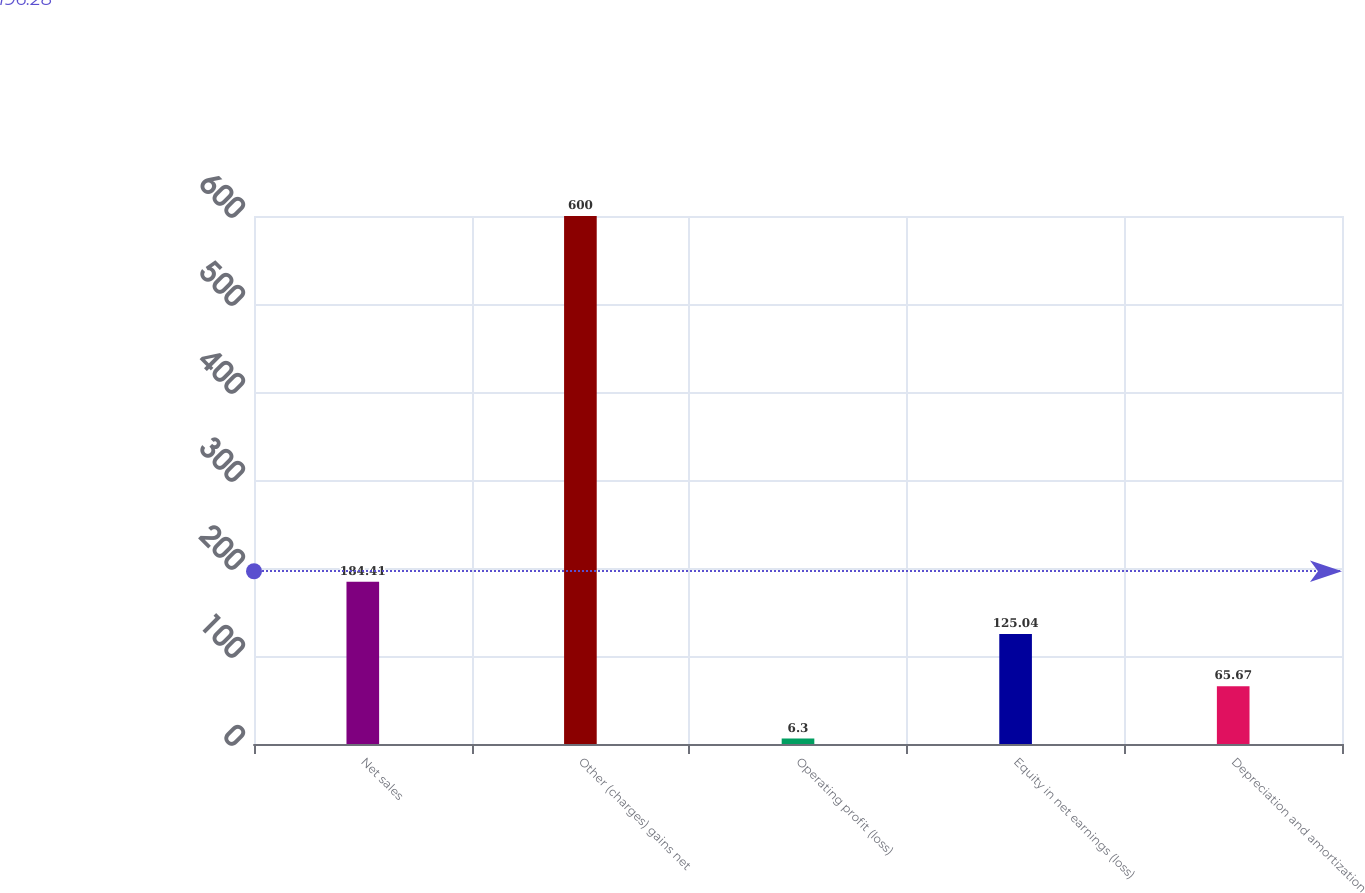<chart> <loc_0><loc_0><loc_500><loc_500><bar_chart><fcel>Net sales<fcel>Other (charges) gains net<fcel>Operating profit (loss)<fcel>Equity in net earnings (loss)<fcel>Depreciation and amortization<nl><fcel>184.41<fcel>600<fcel>6.3<fcel>125.04<fcel>65.67<nl></chart> 